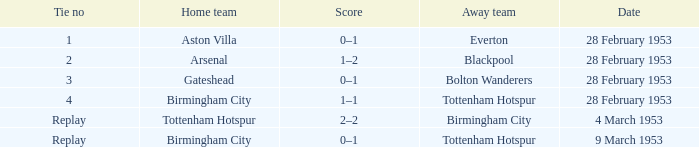Which Tie no has a Score of 0–1, and a Date of 9 march 1953? Replay. 